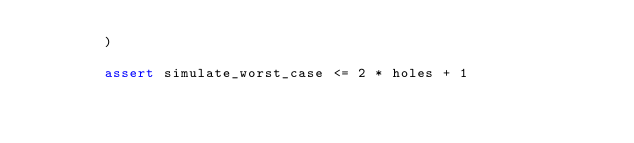Convert code to text. <code><loc_0><loc_0><loc_500><loc_500><_Python_>        )

        assert simulate_worst_case <= 2 * holes + 1
</code> 